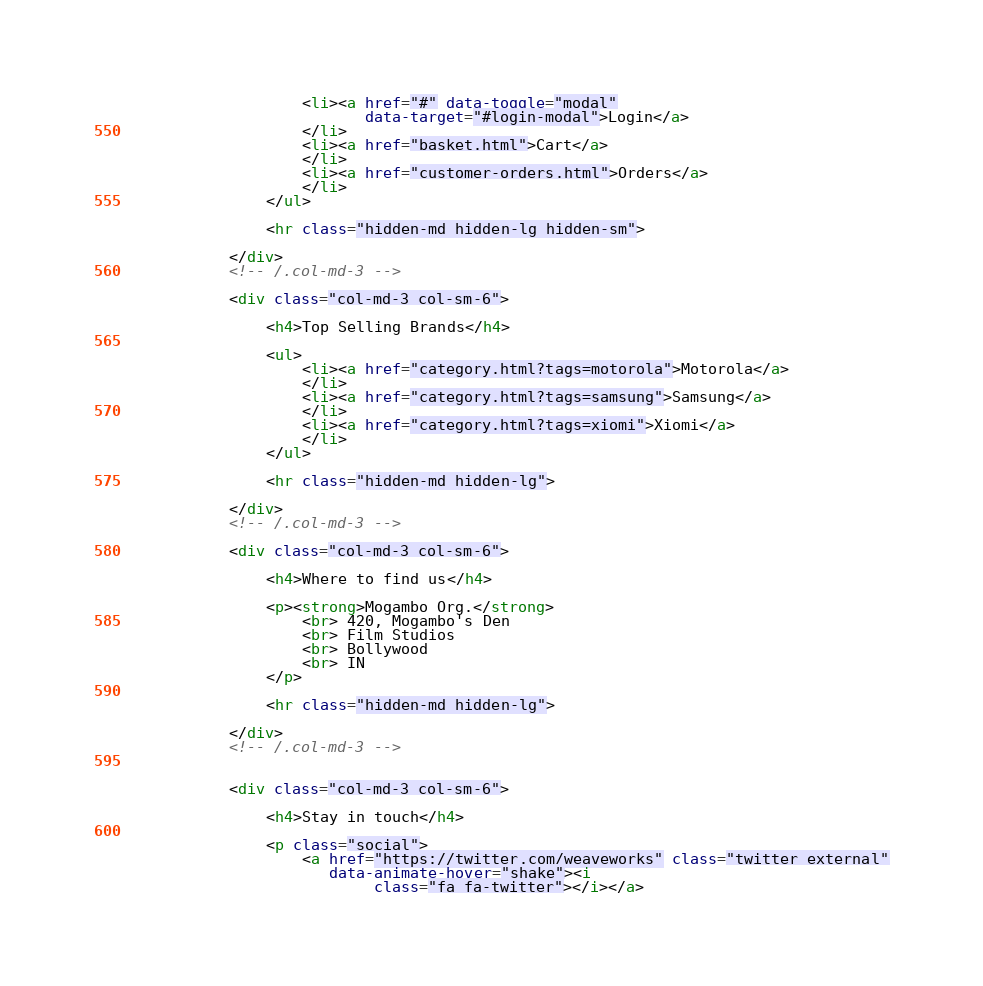<code> <loc_0><loc_0><loc_500><loc_500><_HTML_>                    <li><a href="#" data-toggle="modal"
                           data-target="#login-modal">Login</a>
                    </li>
                    <li><a href="basket.html">Cart</a>
                    </li>
                    <li><a href="customer-orders.html">Orders</a>
                    </li>
                </ul>

                <hr class="hidden-md hidden-lg hidden-sm">

            </div>
            <!-- /.col-md-3 -->

            <div class="col-md-3 col-sm-6">

                <h4>Top Selling Brands</h4>

                <ul>
                    <li><a href="category.html?tags=motorola">Motorola</a>
                    </li>
                    <li><a href="category.html?tags=samsung">Samsung</a>
                    </li>
                    <li><a href="category.html?tags=xiomi">Xiomi</a>
                    </li>
                </ul>

                <hr class="hidden-md hidden-lg">

            </div>
            <!-- /.col-md-3 -->

            <div class="col-md-3 col-sm-6">

                <h4>Where to find us</h4>

                <p><strong>Mogambo Org.</strong>
                    <br> 420, Mogambo's Den
                    <br> Film Studios
                    <br> Bollywood
                    <br> IN
                </p>

                <hr class="hidden-md hidden-lg">

            </div>
            <!-- /.col-md-3 -->


            <div class="col-md-3 col-sm-6">

                <h4>Stay in touch</h4>

                <p class="social">
                    <a href="https://twitter.com/weaveworks" class="twitter external"
                       data-animate-hover="shake"><i
                            class="fa fa-twitter"></i></a></code> 